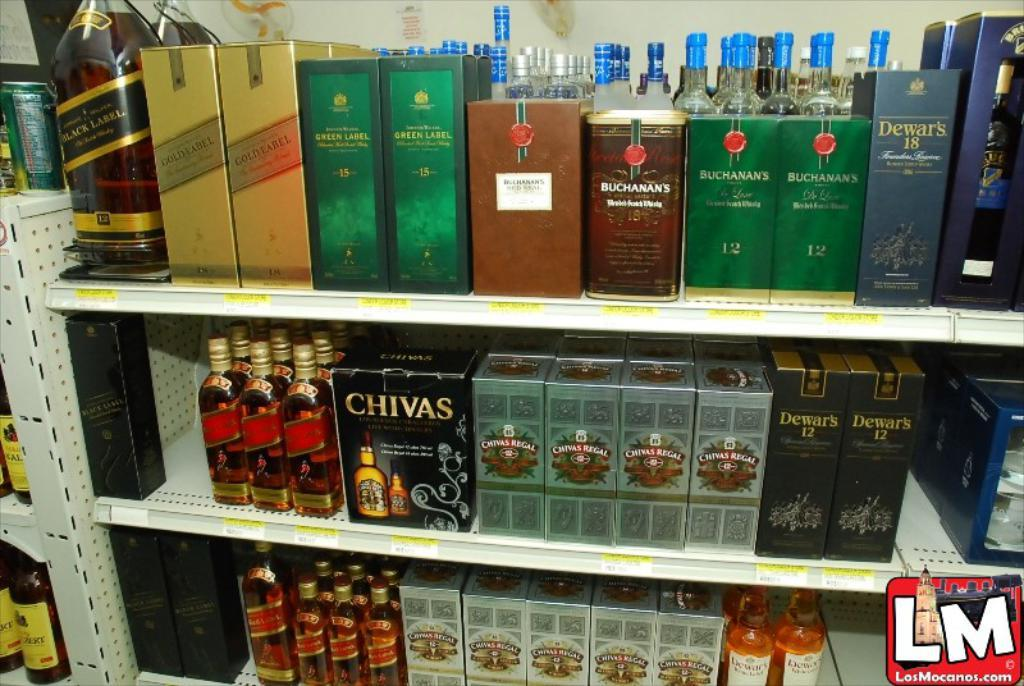What type of objects can be seen in the image? There are bottles and boxes in the image. What else is visible in the image? The tracks and a wall are visible in the image. Is there any text present in the image? Yes, there is text present in the image. Can you tell me how much money is being exchanged in the image? There is no money being exchanged in the image; it only features bottles, boxes, tracks, a wall, and text. What time of day is depicted in the image? The image does not show a specific time of day, as it only contains bottles, boxes, tracks, a wall, and text. 